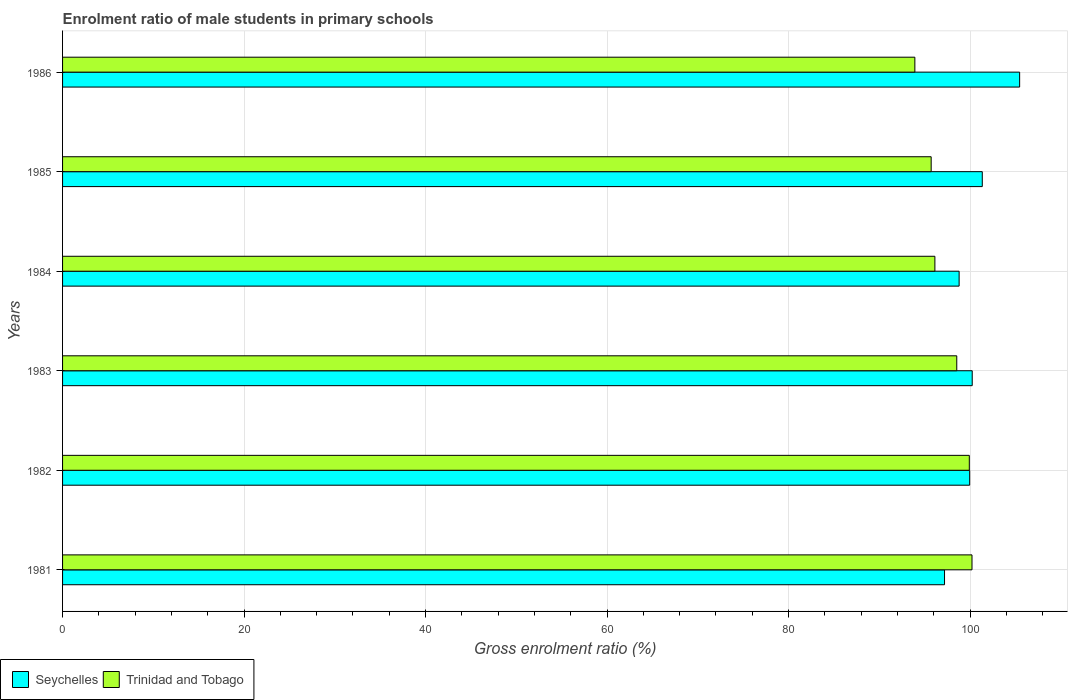How many groups of bars are there?
Offer a very short reply. 6. Are the number of bars per tick equal to the number of legend labels?
Provide a short and direct response. Yes. Are the number of bars on each tick of the Y-axis equal?
Offer a very short reply. Yes. How many bars are there on the 3rd tick from the bottom?
Provide a succinct answer. 2. What is the label of the 2nd group of bars from the top?
Provide a succinct answer. 1985. In how many cases, is the number of bars for a given year not equal to the number of legend labels?
Your response must be concise. 0. What is the enrolment ratio of male students in primary schools in Seychelles in 1984?
Make the answer very short. 98.8. Across all years, what is the maximum enrolment ratio of male students in primary schools in Trinidad and Tobago?
Make the answer very short. 100.22. Across all years, what is the minimum enrolment ratio of male students in primary schools in Trinidad and Tobago?
Offer a terse response. 93.92. In which year was the enrolment ratio of male students in primary schools in Trinidad and Tobago maximum?
Offer a very short reply. 1981. What is the total enrolment ratio of male students in primary schools in Trinidad and Tobago in the graph?
Provide a short and direct response. 584.44. What is the difference between the enrolment ratio of male students in primary schools in Trinidad and Tobago in 1981 and that in 1985?
Provide a succinct answer. 4.5. What is the difference between the enrolment ratio of male students in primary schools in Seychelles in 1983 and the enrolment ratio of male students in primary schools in Trinidad and Tobago in 1982?
Your answer should be very brief. 0.32. What is the average enrolment ratio of male students in primary schools in Trinidad and Tobago per year?
Provide a succinct answer. 97.41. In the year 1985, what is the difference between the enrolment ratio of male students in primary schools in Trinidad and Tobago and enrolment ratio of male students in primary schools in Seychelles?
Keep it short and to the point. -5.63. In how many years, is the enrolment ratio of male students in primary schools in Trinidad and Tobago greater than 36 %?
Keep it short and to the point. 6. What is the ratio of the enrolment ratio of male students in primary schools in Seychelles in 1981 to that in 1982?
Your response must be concise. 0.97. Is the difference between the enrolment ratio of male students in primary schools in Trinidad and Tobago in 1981 and 1982 greater than the difference between the enrolment ratio of male students in primary schools in Seychelles in 1981 and 1982?
Your response must be concise. Yes. What is the difference between the highest and the second highest enrolment ratio of male students in primary schools in Trinidad and Tobago?
Offer a terse response. 0.29. What is the difference between the highest and the lowest enrolment ratio of male students in primary schools in Trinidad and Tobago?
Your response must be concise. 6.3. In how many years, is the enrolment ratio of male students in primary schools in Trinidad and Tobago greater than the average enrolment ratio of male students in primary schools in Trinidad and Tobago taken over all years?
Ensure brevity in your answer.  3. What does the 2nd bar from the top in 1981 represents?
Keep it short and to the point. Seychelles. What does the 1st bar from the bottom in 1985 represents?
Your response must be concise. Seychelles. Does the graph contain any zero values?
Give a very brief answer. No. Does the graph contain grids?
Provide a succinct answer. Yes. What is the title of the graph?
Your response must be concise. Enrolment ratio of male students in primary schools. Does "Suriname" appear as one of the legend labels in the graph?
Provide a succinct answer. No. What is the Gross enrolment ratio (%) of Seychelles in 1981?
Your answer should be compact. 97.19. What is the Gross enrolment ratio (%) in Trinidad and Tobago in 1981?
Your answer should be very brief. 100.22. What is the Gross enrolment ratio (%) in Seychelles in 1982?
Keep it short and to the point. 99.96. What is the Gross enrolment ratio (%) in Trinidad and Tobago in 1982?
Provide a short and direct response. 99.92. What is the Gross enrolment ratio (%) in Seychelles in 1983?
Make the answer very short. 100.24. What is the Gross enrolment ratio (%) in Trinidad and Tobago in 1983?
Provide a succinct answer. 98.54. What is the Gross enrolment ratio (%) in Seychelles in 1984?
Your answer should be compact. 98.8. What is the Gross enrolment ratio (%) of Trinidad and Tobago in 1984?
Your answer should be very brief. 96.13. What is the Gross enrolment ratio (%) in Seychelles in 1985?
Provide a succinct answer. 101.35. What is the Gross enrolment ratio (%) of Trinidad and Tobago in 1985?
Your answer should be very brief. 95.72. What is the Gross enrolment ratio (%) in Seychelles in 1986?
Provide a short and direct response. 105.47. What is the Gross enrolment ratio (%) in Trinidad and Tobago in 1986?
Keep it short and to the point. 93.92. Across all years, what is the maximum Gross enrolment ratio (%) in Seychelles?
Offer a very short reply. 105.47. Across all years, what is the maximum Gross enrolment ratio (%) of Trinidad and Tobago?
Make the answer very short. 100.22. Across all years, what is the minimum Gross enrolment ratio (%) of Seychelles?
Give a very brief answer. 97.19. Across all years, what is the minimum Gross enrolment ratio (%) of Trinidad and Tobago?
Offer a terse response. 93.92. What is the total Gross enrolment ratio (%) in Seychelles in the graph?
Make the answer very short. 603. What is the total Gross enrolment ratio (%) of Trinidad and Tobago in the graph?
Give a very brief answer. 584.44. What is the difference between the Gross enrolment ratio (%) in Seychelles in 1981 and that in 1982?
Provide a short and direct response. -2.77. What is the difference between the Gross enrolment ratio (%) of Trinidad and Tobago in 1981 and that in 1982?
Offer a terse response. 0.29. What is the difference between the Gross enrolment ratio (%) of Seychelles in 1981 and that in 1983?
Your response must be concise. -3.05. What is the difference between the Gross enrolment ratio (%) of Trinidad and Tobago in 1981 and that in 1983?
Make the answer very short. 1.68. What is the difference between the Gross enrolment ratio (%) of Seychelles in 1981 and that in 1984?
Ensure brevity in your answer.  -1.61. What is the difference between the Gross enrolment ratio (%) in Trinidad and Tobago in 1981 and that in 1984?
Offer a very short reply. 4.09. What is the difference between the Gross enrolment ratio (%) of Seychelles in 1981 and that in 1985?
Offer a terse response. -4.16. What is the difference between the Gross enrolment ratio (%) of Trinidad and Tobago in 1981 and that in 1985?
Keep it short and to the point. 4.5. What is the difference between the Gross enrolment ratio (%) of Seychelles in 1981 and that in 1986?
Make the answer very short. -8.28. What is the difference between the Gross enrolment ratio (%) in Trinidad and Tobago in 1981 and that in 1986?
Your response must be concise. 6.3. What is the difference between the Gross enrolment ratio (%) of Seychelles in 1982 and that in 1983?
Keep it short and to the point. -0.28. What is the difference between the Gross enrolment ratio (%) in Trinidad and Tobago in 1982 and that in 1983?
Provide a succinct answer. 1.38. What is the difference between the Gross enrolment ratio (%) of Seychelles in 1982 and that in 1984?
Your response must be concise. 1.16. What is the difference between the Gross enrolment ratio (%) in Trinidad and Tobago in 1982 and that in 1984?
Make the answer very short. 3.79. What is the difference between the Gross enrolment ratio (%) in Seychelles in 1982 and that in 1985?
Ensure brevity in your answer.  -1.39. What is the difference between the Gross enrolment ratio (%) in Trinidad and Tobago in 1982 and that in 1985?
Make the answer very short. 4.2. What is the difference between the Gross enrolment ratio (%) of Seychelles in 1982 and that in 1986?
Give a very brief answer. -5.51. What is the difference between the Gross enrolment ratio (%) in Trinidad and Tobago in 1982 and that in 1986?
Provide a succinct answer. 6. What is the difference between the Gross enrolment ratio (%) of Seychelles in 1983 and that in 1984?
Provide a succinct answer. 1.44. What is the difference between the Gross enrolment ratio (%) in Trinidad and Tobago in 1983 and that in 1984?
Your response must be concise. 2.41. What is the difference between the Gross enrolment ratio (%) in Seychelles in 1983 and that in 1985?
Offer a very short reply. -1.11. What is the difference between the Gross enrolment ratio (%) of Trinidad and Tobago in 1983 and that in 1985?
Offer a terse response. 2.82. What is the difference between the Gross enrolment ratio (%) of Seychelles in 1983 and that in 1986?
Ensure brevity in your answer.  -5.23. What is the difference between the Gross enrolment ratio (%) of Trinidad and Tobago in 1983 and that in 1986?
Make the answer very short. 4.62. What is the difference between the Gross enrolment ratio (%) in Seychelles in 1984 and that in 1985?
Provide a short and direct response. -2.55. What is the difference between the Gross enrolment ratio (%) in Trinidad and Tobago in 1984 and that in 1985?
Provide a short and direct response. 0.41. What is the difference between the Gross enrolment ratio (%) of Seychelles in 1984 and that in 1986?
Your response must be concise. -6.67. What is the difference between the Gross enrolment ratio (%) in Trinidad and Tobago in 1984 and that in 1986?
Keep it short and to the point. 2.21. What is the difference between the Gross enrolment ratio (%) of Seychelles in 1985 and that in 1986?
Provide a succinct answer. -4.12. What is the difference between the Gross enrolment ratio (%) in Trinidad and Tobago in 1985 and that in 1986?
Offer a terse response. 1.8. What is the difference between the Gross enrolment ratio (%) of Seychelles in 1981 and the Gross enrolment ratio (%) of Trinidad and Tobago in 1982?
Offer a very short reply. -2.73. What is the difference between the Gross enrolment ratio (%) in Seychelles in 1981 and the Gross enrolment ratio (%) in Trinidad and Tobago in 1983?
Offer a very short reply. -1.35. What is the difference between the Gross enrolment ratio (%) of Seychelles in 1981 and the Gross enrolment ratio (%) of Trinidad and Tobago in 1984?
Offer a very short reply. 1.06. What is the difference between the Gross enrolment ratio (%) of Seychelles in 1981 and the Gross enrolment ratio (%) of Trinidad and Tobago in 1985?
Your answer should be very brief. 1.47. What is the difference between the Gross enrolment ratio (%) in Seychelles in 1981 and the Gross enrolment ratio (%) in Trinidad and Tobago in 1986?
Offer a terse response. 3.27. What is the difference between the Gross enrolment ratio (%) in Seychelles in 1982 and the Gross enrolment ratio (%) in Trinidad and Tobago in 1983?
Keep it short and to the point. 1.42. What is the difference between the Gross enrolment ratio (%) in Seychelles in 1982 and the Gross enrolment ratio (%) in Trinidad and Tobago in 1984?
Offer a very short reply. 3.83. What is the difference between the Gross enrolment ratio (%) of Seychelles in 1982 and the Gross enrolment ratio (%) of Trinidad and Tobago in 1985?
Your answer should be compact. 4.24. What is the difference between the Gross enrolment ratio (%) in Seychelles in 1982 and the Gross enrolment ratio (%) in Trinidad and Tobago in 1986?
Provide a short and direct response. 6.04. What is the difference between the Gross enrolment ratio (%) in Seychelles in 1983 and the Gross enrolment ratio (%) in Trinidad and Tobago in 1984?
Keep it short and to the point. 4.11. What is the difference between the Gross enrolment ratio (%) of Seychelles in 1983 and the Gross enrolment ratio (%) of Trinidad and Tobago in 1985?
Provide a succinct answer. 4.52. What is the difference between the Gross enrolment ratio (%) in Seychelles in 1983 and the Gross enrolment ratio (%) in Trinidad and Tobago in 1986?
Your response must be concise. 6.32. What is the difference between the Gross enrolment ratio (%) of Seychelles in 1984 and the Gross enrolment ratio (%) of Trinidad and Tobago in 1985?
Offer a very short reply. 3.08. What is the difference between the Gross enrolment ratio (%) of Seychelles in 1984 and the Gross enrolment ratio (%) of Trinidad and Tobago in 1986?
Your answer should be compact. 4.88. What is the difference between the Gross enrolment ratio (%) in Seychelles in 1985 and the Gross enrolment ratio (%) in Trinidad and Tobago in 1986?
Give a very brief answer. 7.43. What is the average Gross enrolment ratio (%) in Seychelles per year?
Your response must be concise. 100.5. What is the average Gross enrolment ratio (%) in Trinidad and Tobago per year?
Ensure brevity in your answer.  97.41. In the year 1981, what is the difference between the Gross enrolment ratio (%) in Seychelles and Gross enrolment ratio (%) in Trinidad and Tobago?
Your response must be concise. -3.03. In the year 1982, what is the difference between the Gross enrolment ratio (%) in Seychelles and Gross enrolment ratio (%) in Trinidad and Tobago?
Your response must be concise. 0.04. In the year 1983, what is the difference between the Gross enrolment ratio (%) in Seychelles and Gross enrolment ratio (%) in Trinidad and Tobago?
Provide a short and direct response. 1.7. In the year 1984, what is the difference between the Gross enrolment ratio (%) in Seychelles and Gross enrolment ratio (%) in Trinidad and Tobago?
Give a very brief answer. 2.67. In the year 1985, what is the difference between the Gross enrolment ratio (%) in Seychelles and Gross enrolment ratio (%) in Trinidad and Tobago?
Your answer should be very brief. 5.63. In the year 1986, what is the difference between the Gross enrolment ratio (%) of Seychelles and Gross enrolment ratio (%) of Trinidad and Tobago?
Give a very brief answer. 11.55. What is the ratio of the Gross enrolment ratio (%) of Seychelles in 1981 to that in 1982?
Provide a short and direct response. 0.97. What is the ratio of the Gross enrolment ratio (%) in Trinidad and Tobago in 1981 to that in 1982?
Make the answer very short. 1. What is the ratio of the Gross enrolment ratio (%) in Seychelles in 1981 to that in 1983?
Ensure brevity in your answer.  0.97. What is the ratio of the Gross enrolment ratio (%) in Seychelles in 1981 to that in 1984?
Your answer should be very brief. 0.98. What is the ratio of the Gross enrolment ratio (%) in Trinidad and Tobago in 1981 to that in 1984?
Your answer should be compact. 1.04. What is the ratio of the Gross enrolment ratio (%) in Seychelles in 1981 to that in 1985?
Offer a very short reply. 0.96. What is the ratio of the Gross enrolment ratio (%) in Trinidad and Tobago in 1981 to that in 1985?
Your answer should be compact. 1.05. What is the ratio of the Gross enrolment ratio (%) of Seychelles in 1981 to that in 1986?
Offer a very short reply. 0.92. What is the ratio of the Gross enrolment ratio (%) of Trinidad and Tobago in 1981 to that in 1986?
Provide a short and direct response. 1.07. What is the ratio of the Gross enrolment ratio (%) in Seychelles in 1982 to that in 1983?
Your answer should be compact. 1. What is the ratio of the Gross enrolment ratio (%) of Trinidad and Tobago in 1982 to that in 1983?
Your answer should be compact. 1.01. What is the ratio of the Gross enrolment ratio (%) in Seychelles in 1982 to that in 1984?
Give a very brief answer. 1.01. What is the ratio of the Gross enrolment ratio (%) in Trinidad and Tobago in 1982 to that in 1984?
Keep it short and to the point. 1.04. What is the ratio of the Gross enrolment ratio (%) in Seychelles in 1982 to that in 1985?
Make the answer very short. 0.99. What is the ratio of the Gross enrolment ratio (%) in Trinidad and Tobago in 1982 to that in 1985?
Your answer should be very brief. 1.04. What is the ratio of the Gross enrolment ratio (%) in Seychelles in 1982 to that in 1986?
Provide a short and direct response. 0.95. What is the ratio of the Gross enrolment ratio (%) of Trinidad and Tobago in 1982 to that in 1986?
Your response must be concise. 1.06. What is the ratio of the Gross enrolment ratio (%) in Seychelles in 1983 to that in 1984?
Offer a terse response. 1.01. What is the ratio of the Gross enrolment ratio (%) of Trinidad and Tobago in 1983 to that in 1984?
Offer a terse response. 1.03. What is the ratio of the Gross enrolment ratio (%) in Seychelles in 1983 to that in 1985?
Give a very brief answer. 0.99. What is the ratio of the Gross enrolment ratio (%) of Trinidad and Tobago in 1983 to that in 1985?
Keep it short and to the point. 1.03. What is the ratio of the Gross enrolment ratio (%) in Seychelles in 1983 to that in 1986?
Your response must be concise. 0.95. What is the ratio of the Gross enrolment ratio (%) of Trinidad and Tobago in 1983 to that in 1986?
Your response must be concise. 1.05. What is the ratio of the Gross enrolment ratio (%) of Seychelles in 1984 to that in 1985?
Provide a succinct answer. 0.97. What is the ratio of the Gross enrolment ratio (%) of Seychelles in 1984 to that in 1986?
Provide a short and direct response. 0.94. What is the ratio of the Gross enrolment ratio (%) of Trinidad and Tobago in 1984 to that in 1986?
Your answer should be very brief. 1.02. What is the ratio of the Gross enrolment ratio (%) in Seychelles in 1985 to that in 1986?
Ensure brevity in your answer.  0.96. What is the ratio of the Gross enrolment ratio (%) of Trinidad and Tobago in 1985 to that in 1986?
Offer a very short reply. 1.02. What is the difference between the highest and the second highest Gross enrolment ratio (%) in Seychelles?
Keep it short and to the point. 4.12. What is the difference between the highest and the second highest Gross enrolment ratio (%) of Trinidad and Tobago?
Provide a succinct answer. 0.29. What is the difference between the highest and the lowest Gross enrolment ratio (%) of Seychelles?
Provide a short and direct response. 8.28. What is the difference between the highest and the lowest Gross enrolment ratio (%) in Trinidad and Tobago?
Your answer should be very brief. 6.3. 